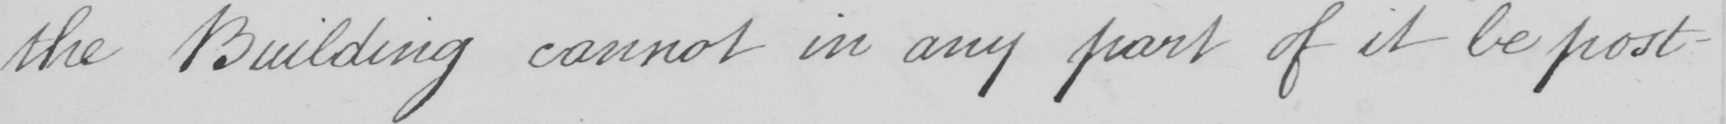Please provide the text content of this handwritten line. the Building cannot in any part of it be post- 